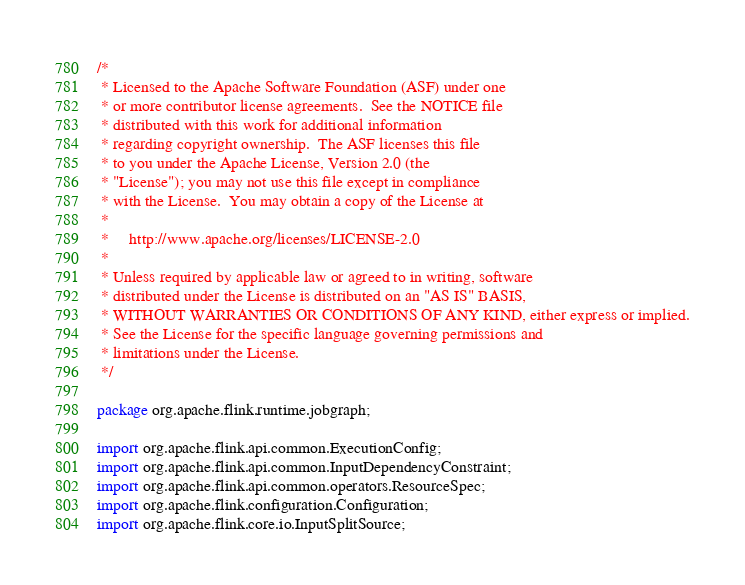<code> <loc_0><loc_0><loc_500><loc_500><_Java_>/*
 * Licensed to the Apache Software Foundation (ASF) under one
 * or more contributor license agreements.  See the NOTICE file
 * distributed with this work for additional information
 * regarding copyright ownership.  The ASF licenses this file
 * to you under the Apache License, Version 2.0 (the
 * "License"); you may not use this file except in compliance
 * with the License.  You may obtain a copy of the License at
 *
 *     http://www.apache.org/licenses/LICENSE-2.0
 *
 * Unless required by applicable law or agreed to in writing, software
 * distributed under the License is distributed on an "AS IS" BASIS,
 * WITHOUT WARRANTIES OR CONDITIONS OF ANY KIND, either express or implied.
 * See the License for the specific language governing permissions and
 * limitations under the License.
 */

package org.apache.flink.runtime.jobgraph;

import org.apache.flink.api.common.ExecutionConfig;
import org.apache.flink.api.common.InputDependencyConstraint;
import org.apache.flink.api.common.operators.ResourceSpec;
import org.apache.flink.configuration.Configuration;
import org.apache.flink.core.io.InputSplitSource;</code> 